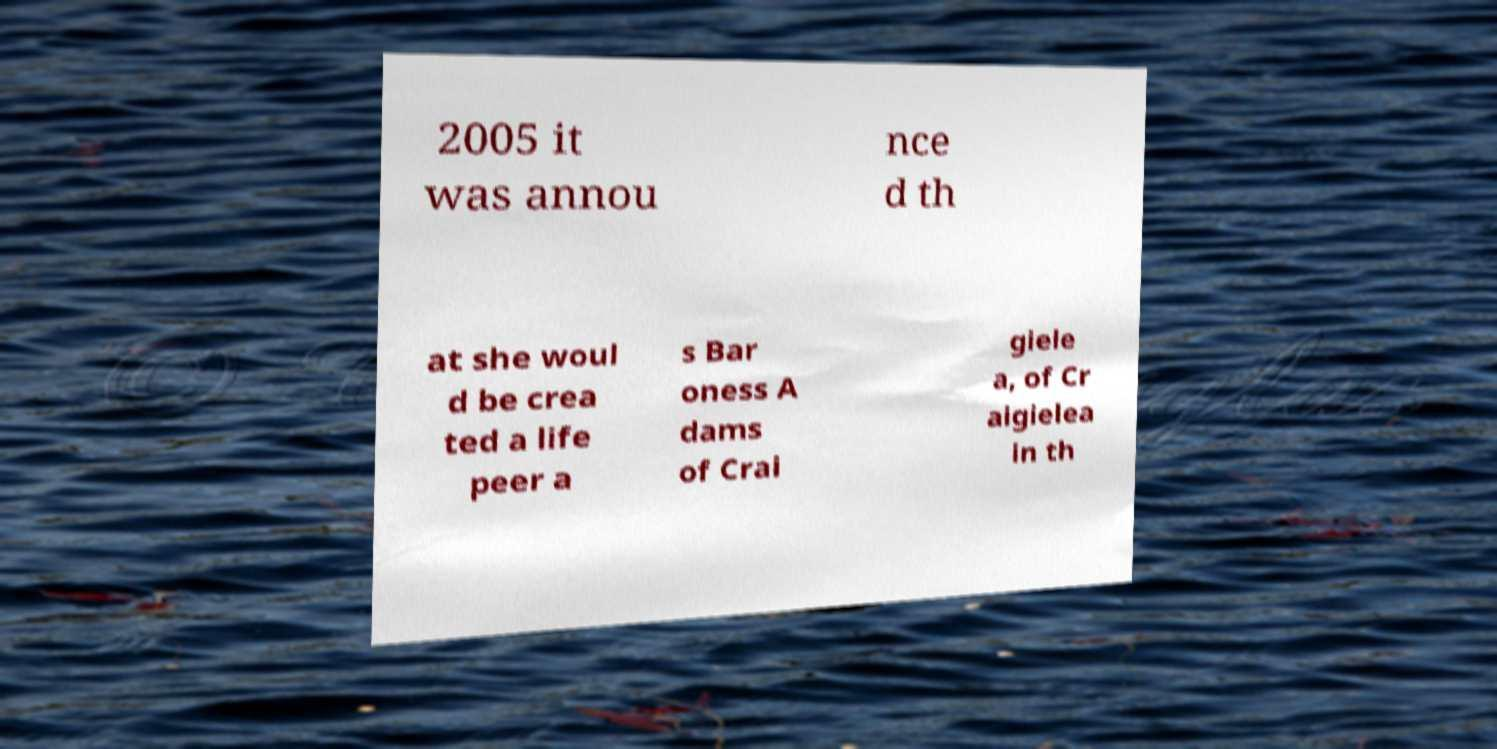Can you accurately transcribe the text from the provided image for me? 2005 it was annou nce d th at she woul d be crea ted a life peer a s Bar oness A dams of Crai giele a, of Cr aigielea in th 